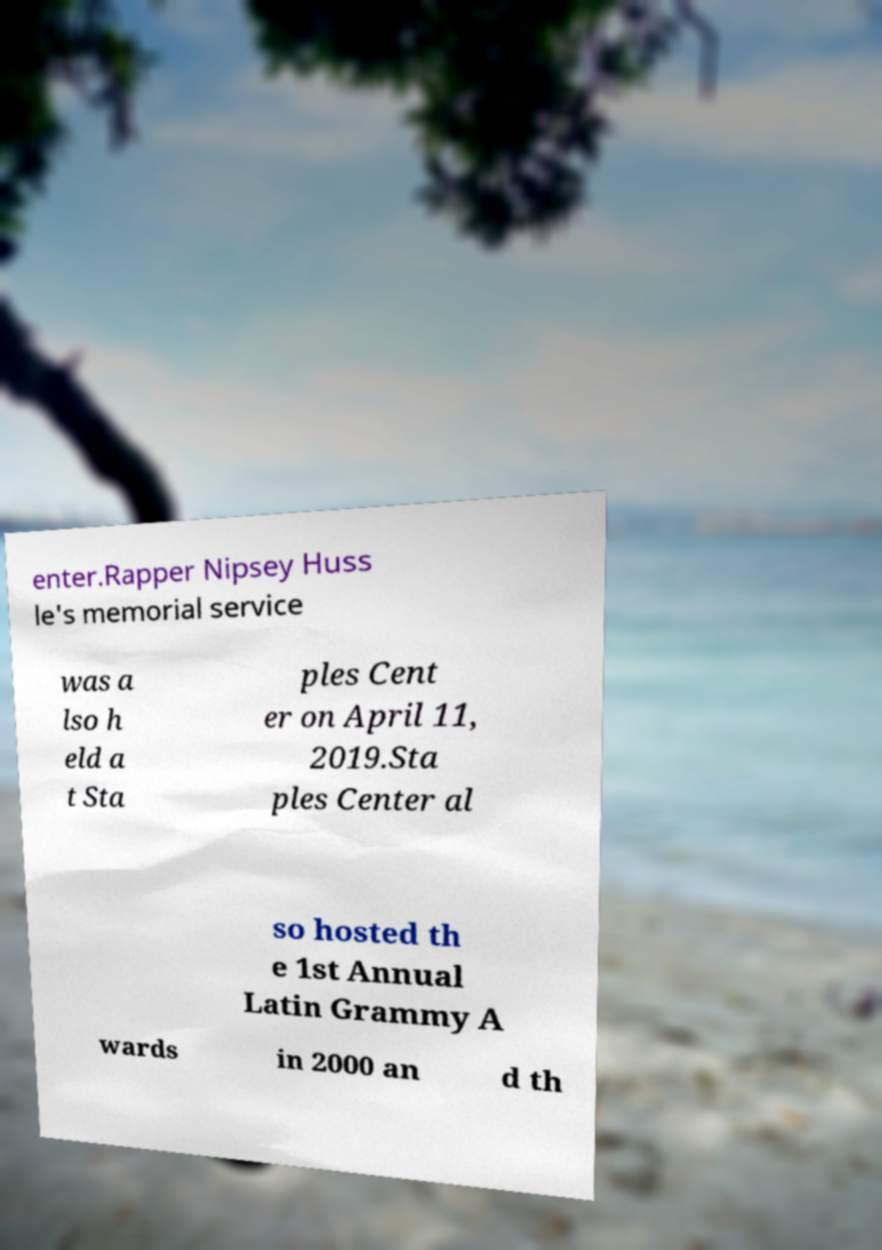I need the written content from this picture converted into text. Can you do that? enter.Rapper Nipsey Huss le's memorial service was a lso h eld a t Sta ples Cent er on April 11, 2019.Sta ples Center al so hosted th e 1st Annual Latin Grammy A wards in 2000 an d th 